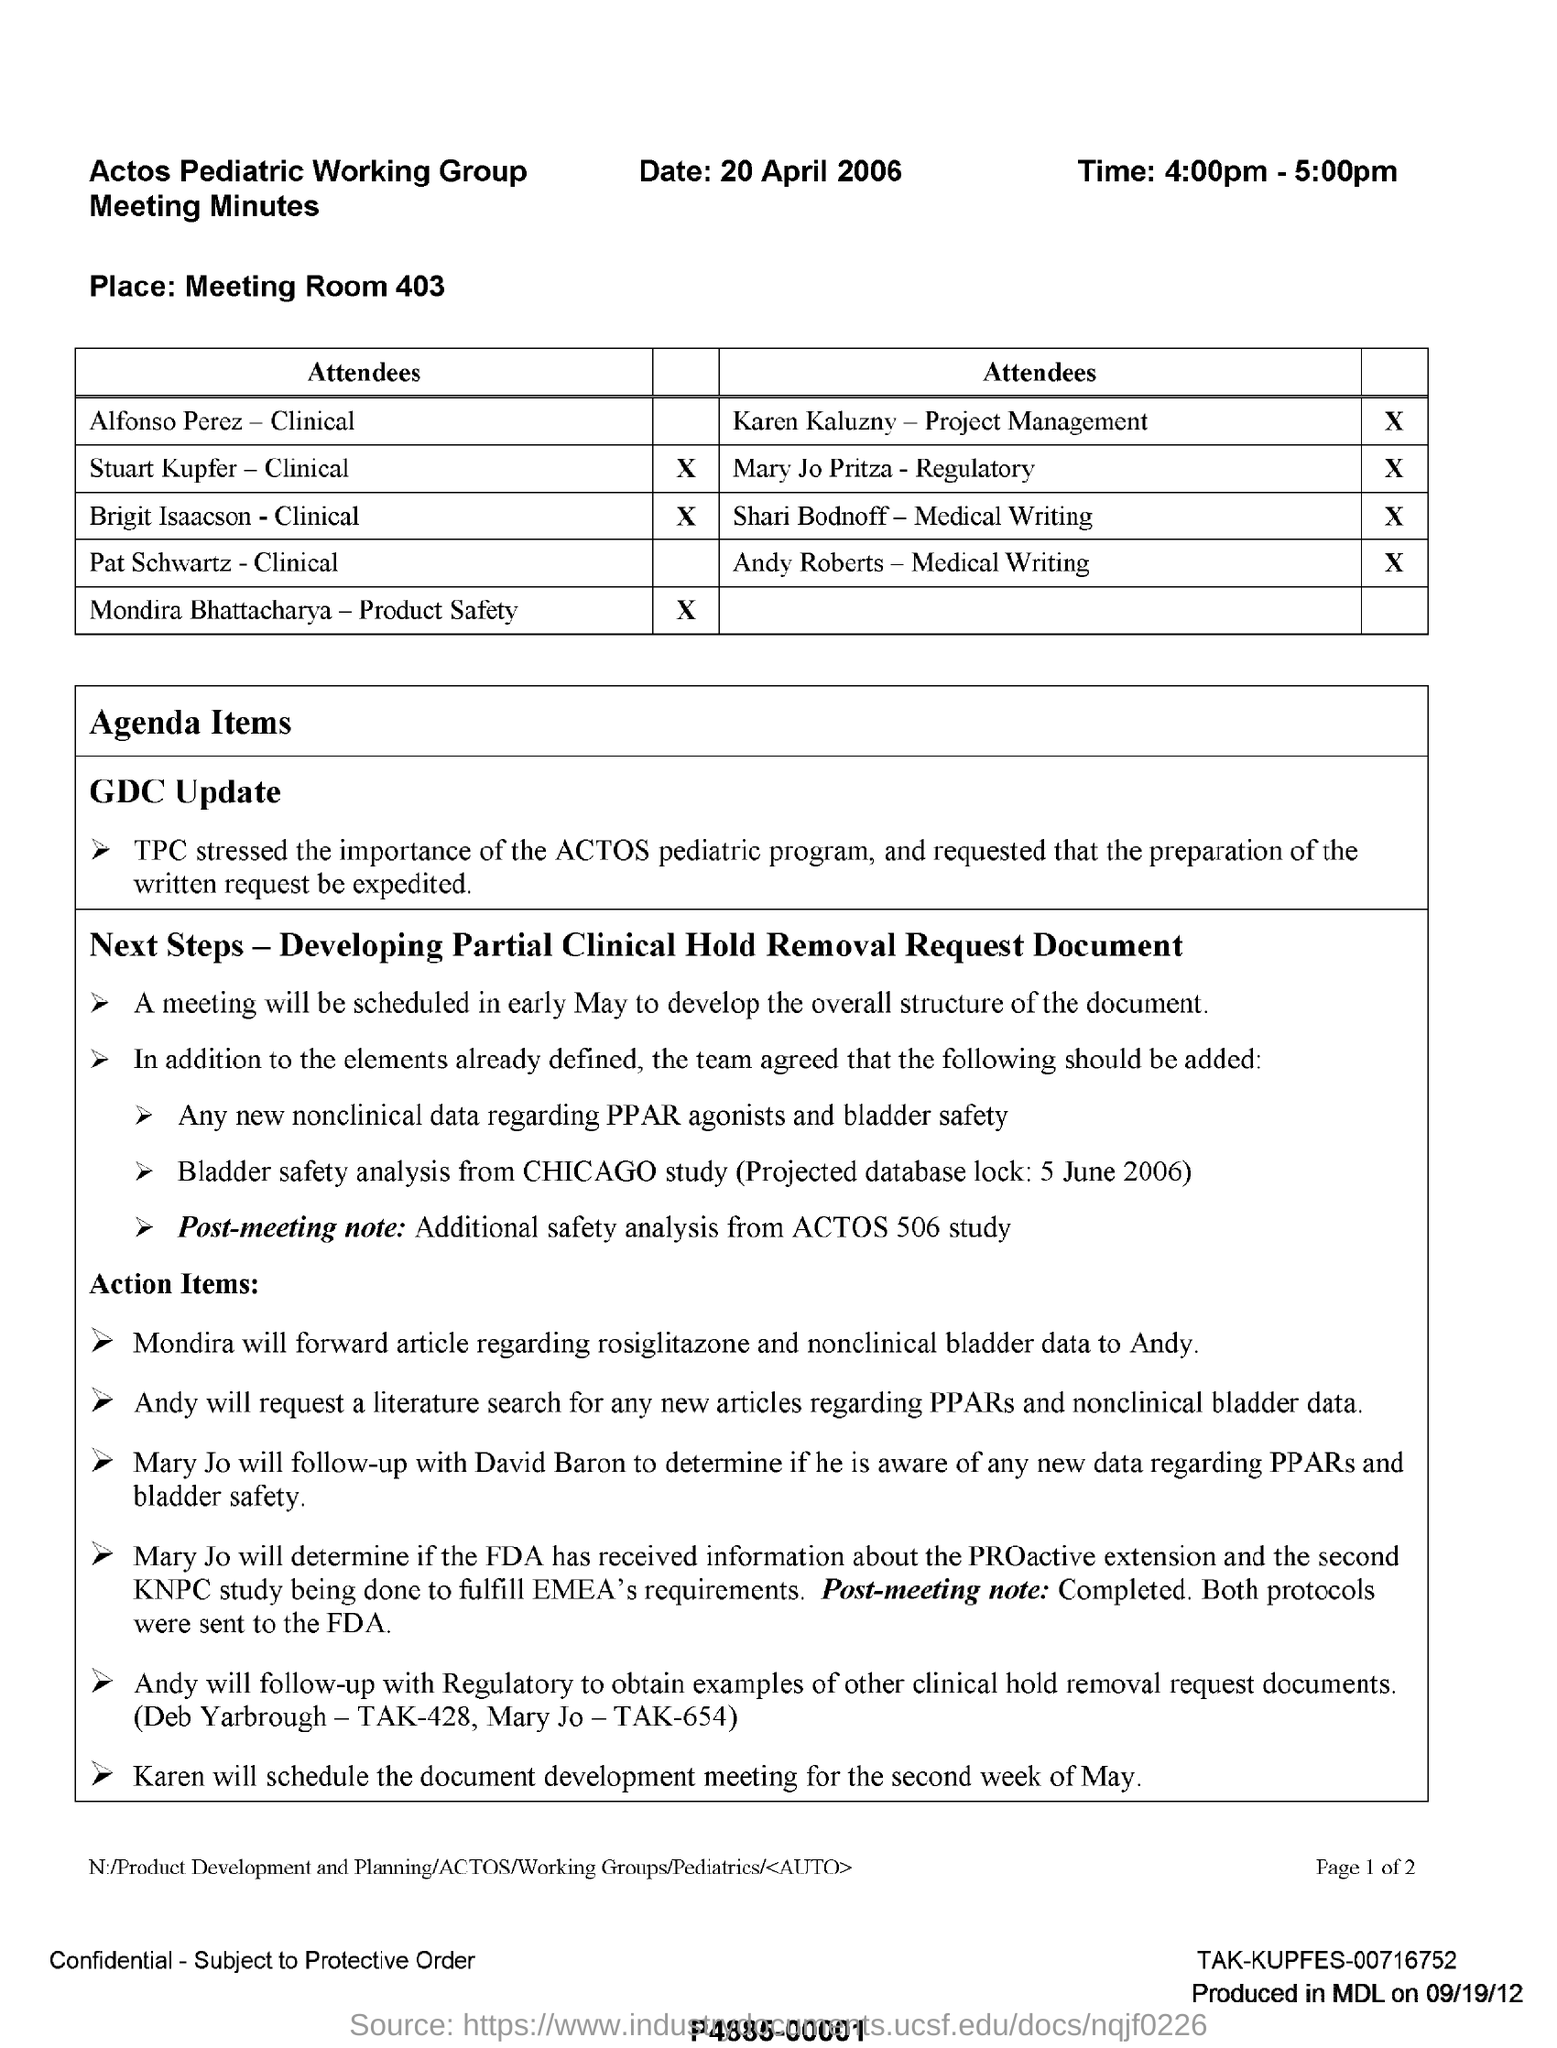Draw attention to some important aspects in this diagram. The meeting is scheduled to take place on a specific date in early May to develop the overall structure of the document. The place mentioned is Meeting Room 403. The date mentioned in the given information is 20 April 2006. The specified meeting time is 4:00pm - 5:00pm. It is necessary to forward the article regarding rosiglitazone and non-clinical bladder data to Andy. Mondira will do so. 